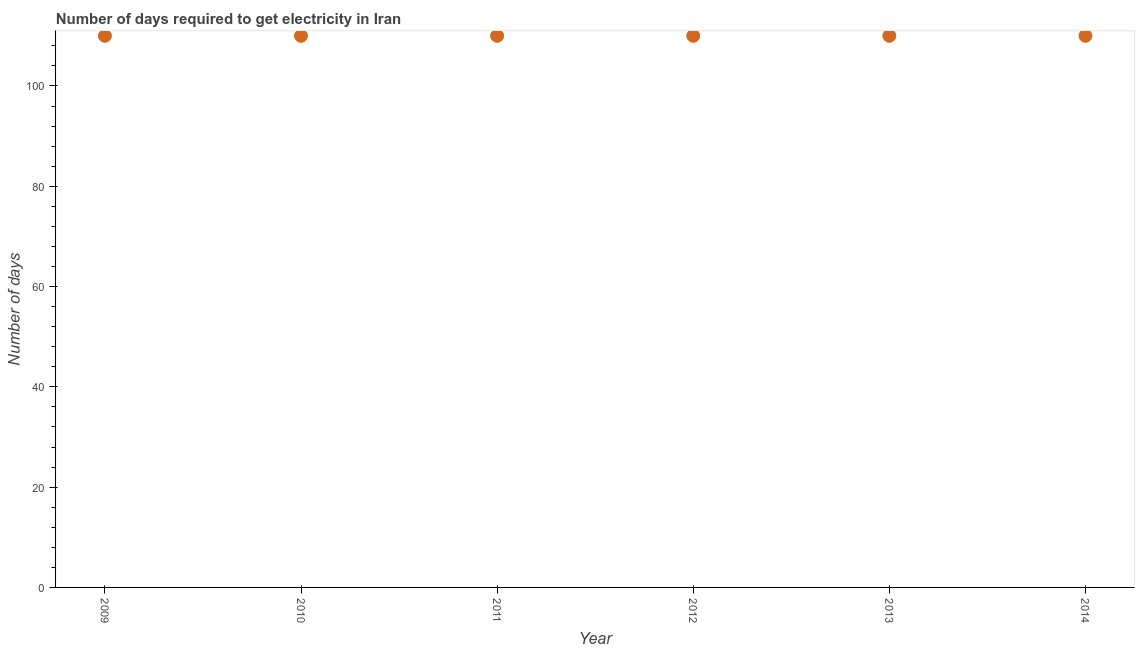What is the time to get electricity in 2011?
Offer a very short reply. 110. Across all years, what is the maximum time to get electricity?
Your response must be concise. 110. Across all years, what is the minimum time to get electricity?
Provide a short and direct response. 110. In which year was the time to get electricity minimum?
Provide a succinct answer. 2009. What is the sum of the time to get electricity?
Ensure brevity in your answer.  660. What is the difference between the time to get electricity in 2009 and 2012?
Offer a very short reply. 0. What is the average time to get electricity per year?
Make the answer very short. 110. What is the median time to get electricity?
Keep it short and to the point. 110. In how many years, is the time to get electricity greater than 32 ?
Offer a terse response. 6. Is the time to get electricity in 2011 less than that in 2013?
Give a very brief answer. No. Is the sum of the time to get electricity in 2009 and 2010 greater than the maximum time to get electricity across all years?
Keep it short and to the point. Yes. In how many years, is the time to get electricity greater than the average time to get electricity taken over all years?
Ensure brevity in your answer.  0. What is the title of the graph?
Ensure brevity in your answer.  Number of days required to get electricity in Iran. What is the label or title of the Y-axis?
Your answer should be very brief. Number of days. What is the Number of days in 2009?
Keep it short and to the point. 110. What is the Number of days in 2010?
Provide a short and direct response. 110. What is the Number of days in 2011?
Provide a short and direct response. 110. What is the Number of days in 2012?
Provide a short and direct response. 110. What is the Number of days in 2013?
Make the answer very short. 110. What is the Number of days in 2014?
Your answer should be compact. 110. What is the difference between the Number of days in 2009 and 2010?
Your response must be concise. 0. What is the difference between the Number of days in 2009 and 2013?
Your response must be concise. 0. What is the difference between the Number of days in 2010 and 2012?
Ensure brevity in your answer.  0. What is the difference between the Number of days in 2010 and 2014?
Make the answer very short. 0. What is the difference between the Number of days in 2011 and 2012?
Offer a terse response. 0. What is the difference between the Number of days in 2011 and 2014?
Your answer should be compact. 0. What is the difference between the Number of days in 2012 and 2014?
Your answer should be very brief. 0. What is the ratio of the Number of days in 2010 to that in 2013?
Offer a very short reply. 1. What is the ratio of the Number of days in 2010 to that in 2014?
Provide a succinct answer. 1. What is the ratio of the Number of days in 2011 to that in 2012?
Provide a short and direct response. 1. What is the ratio of the Number of days in 2012 to that in 2013?
Offer a terse response. 1. 